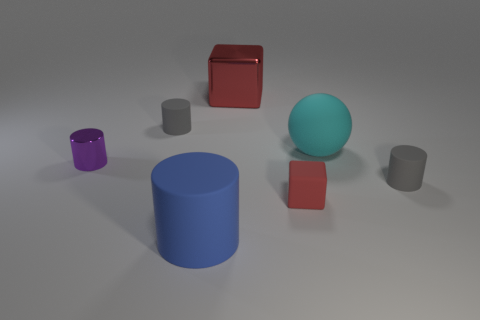Subtract all blue cylinders. How many cylinders are left? 3 Add 2 small metallic things. How many objects exist? 9 Subtract all gray cylinders. How many cylinders are left? 2 Subtract 1 spheres. How many spheres are left? 0 Subtract all cylinders. How many objects are left? 3 Subtract all large yellow shiny cylinders. Subtract all tiny purple cylinders. How many objects are left? 6 Add 4 small purple things. How many small purple things are left? 5 Add 4 big red objects. How many big red objects exist? 5 Subtract 0 green cylinders. How many objects are left? 7 Subtract all cyan cubes. Subtract all gray cylinders. How many cubes are left? 2 